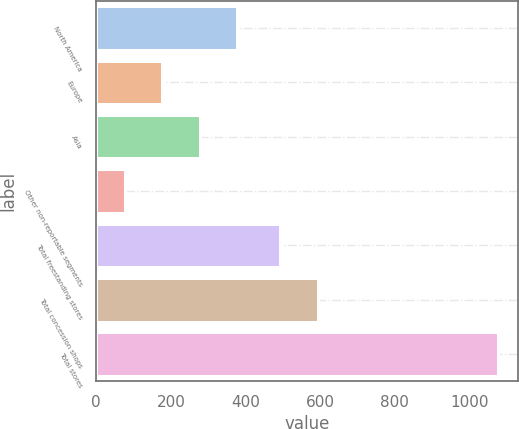<chart> <loc_0><loc_0><loc_500><loc_500><bar_chart><fcel>North America<fcel>Europe<fcel>Asia<fcel>Other non-reportable segments<fcel>Total freestanding stores<fcel>Total concession shops<fcel>Total stores<nl><fcel>376.7<fcel>176.9<fcel>276.8<fcel>77<fcel>493<fcel>592.9<fcel>1076<nl></chart> 